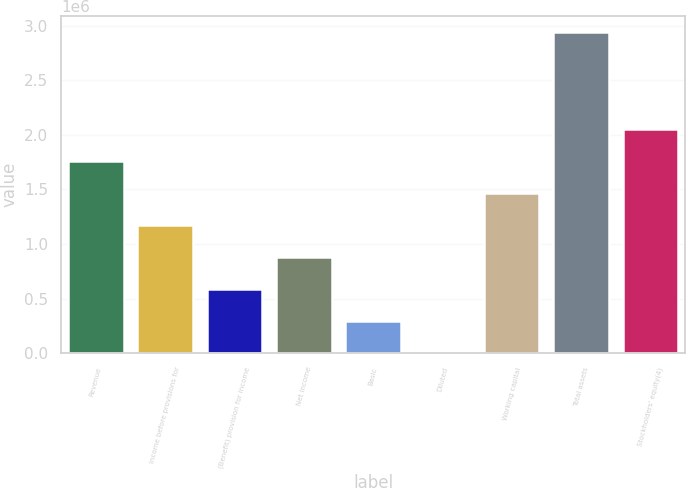<chart> <loc_0><loc_0><loc_500><loc_500><bar_chart><fcel>Revenue<fcel>Income before provisions for<fcel>(Benefit) provision for income<fcel>Net income<fcel>Basic<fcel>Diluted<fcel>Working capital<fcel>Total assets<fcel>Stockholders' equity(4)<nl><fcel>1.76331e+06<fcel>1.17554e+06<fcel>587772<fcel>881657<fcel>293886<fcel>1.15<fcel>1.46943e+06<fcel>2.93885e+06<fcel>2.0572e+06<nl></chart> 